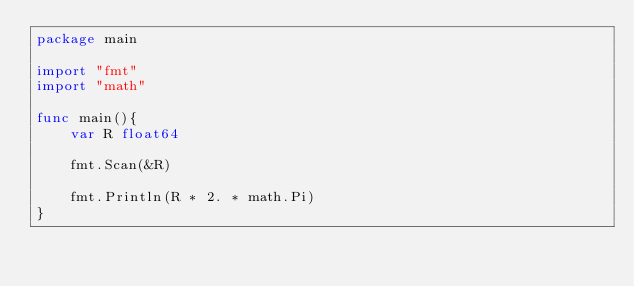Convert code to text. <code><loc_0><loc_0><loc_500><loc_500><_Go_>package main

import "fmt"
import "math"

func main(){
	var R float64

	fmt.Scan(&R)

	fmt.Println(R * 2. * math.Pi)
}</code> 